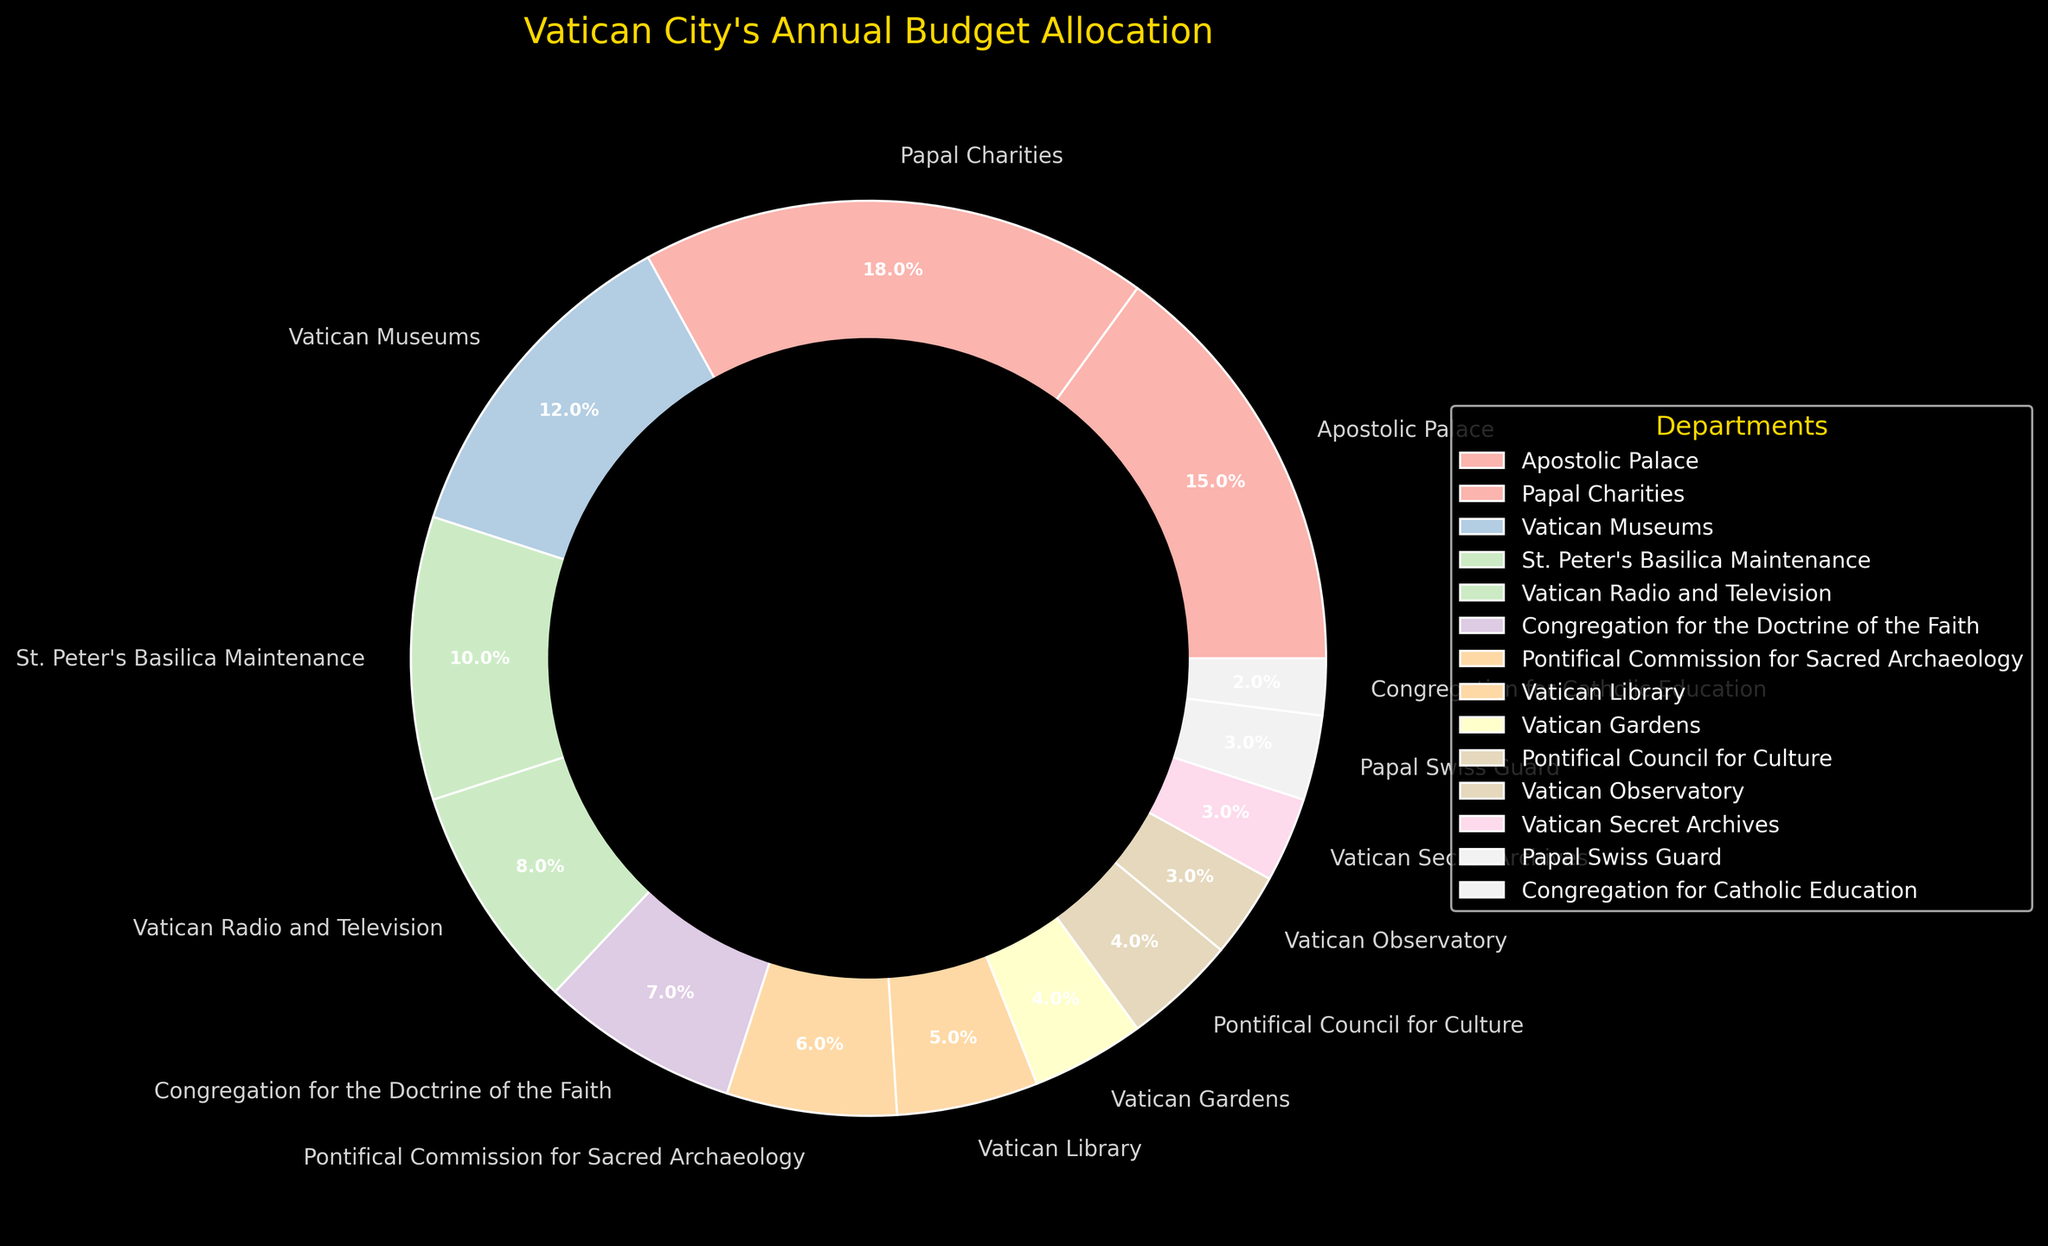What percentage of the budget is allocated to the religious and cultural departments like the Vatican Museums, Vatican Library, Pontifical Commission for Sacred Archaeology, Pontifical Council for Culture, and Congregation for Catholic Education? Add the percentages allocated to the Vatican Museums (12%), Vatican Library (5%), Pontifical Commission for Sacred Archaeology (6%), Pontifical Council for Culture (4%), and Congregation for Catholic Education (2%). This gives 12 + 5 + 6 + 4 + 2 = 29%
Answer: 29% Which department receives a higher budget allocation, St. Peter's Basilica Maintenance or Vatican Radio and Television? Compare the budget allocations of St. Peter's Basilica Maintenance (10%) and Vatican Radio and Television (8%). St. Peter's Basilica Maintenance has a higher allocation than Vatican Radio and Television.
Answer: St. Peter's Basilica Maintenance What is the combined budget allocation for the Vatican Gardens and the Papal Swiss Guard? Add the percentages allocated to the Vatican Gardens (4%) and the Papal Swiss Guard (3%). This gives 4 + 3 = 7%
Answer: 7% Which department has the smallest budget allocation, and what is its percentage? Look for the department with the smallest percentage in the pie chart. The Congregation for Catholic Education has the smallest budget allocation at 2%.
Answer: Congregation for Catholic Education, 2% Is the budget allocation for the Vatican Radio and Television department greater than that for the Congregation for the Doctrine of the Faith? Compare the budget allocations of Vatican Radio and Television (8%) and Congregation for the Doctrine of the Faith (7%). Vatican Radio and Television has a greater allocation than Congregation for the Doctrine of the Faith.
Answer: Yes What is the visual color representation of the Vatican Museums in the pie chart? Identify the color used for the Vatican Museums segment in the pie chart. It is one of the pastel colors used.
Answer: Pastel color How much more is allocated to Papal Charities than to the Vatican Museums? Subtract the budget allocation of the Vatican Museums (12%) from Papal Charities (18%). This gives 18 - 12 = 6%
Answer: 6% What is the average budget allocation for the departments with allocations of 5% or less? Identify the departments with allocations of 5% or less: Vatican Library (5%), Vatican Gardens (4%), Pontifical Council for Culture (4%), Vatican Observatory (3%), Vatican Secret Archives (3%), Papal Swiss Guard (3%), Congregation for Catholic Education (2%). Sum these allocations and divide by the number of departments: (5 + 4 + 4 + 3 + 3 + 3 + 2) / 7 = 3.43%
Answer: 3.43% Which department has a color closest to blue? Identify the department with the segment color closest to blue in the pie chart, given that the color scheme is pastel. The Vatican Observatory segment is closest to blue.
Answer: Vatican Observatory 